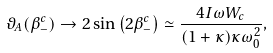Convert formula to latex. <formula><loc_0><loc_0><loc_500><loc_500>\vartheta _ { A } ( \beta _ { - } ^ { c } ) \to 2 \sin \left ( 2 \beta _ { - } ^ { c } \right ) \simeq \frac { 4 I \omega W _ { c } } { ( 1 + \kappa ) \kappa \omega _ { 0 } ^ { 2 } } ,</formula> 